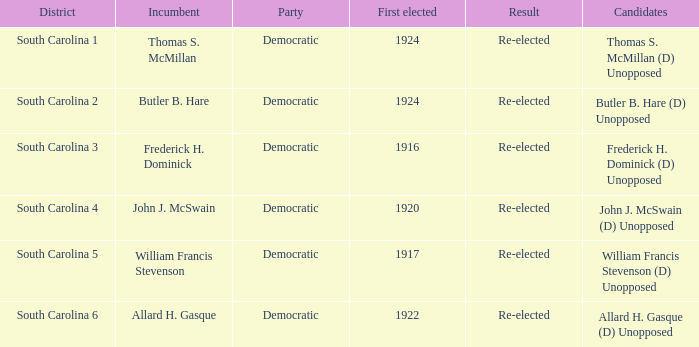What is the celebration for south carolina 3? Democratic. 